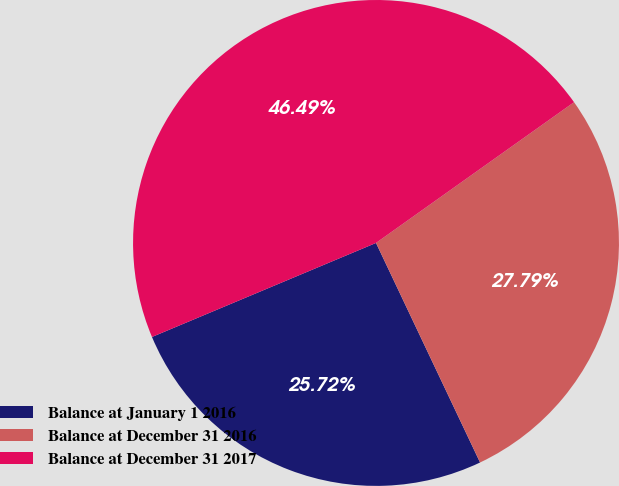<chart> <loc_0><loc_0><loc_500><loc_500><pie_chart><fcel>Balance at January 1 2016<fcel>Balance at December 31 2016<fcel>Balance at December 31 2017<nl><fcel>25.72%<fcel>27.79%<fcel>46.49%<nl></chart> 